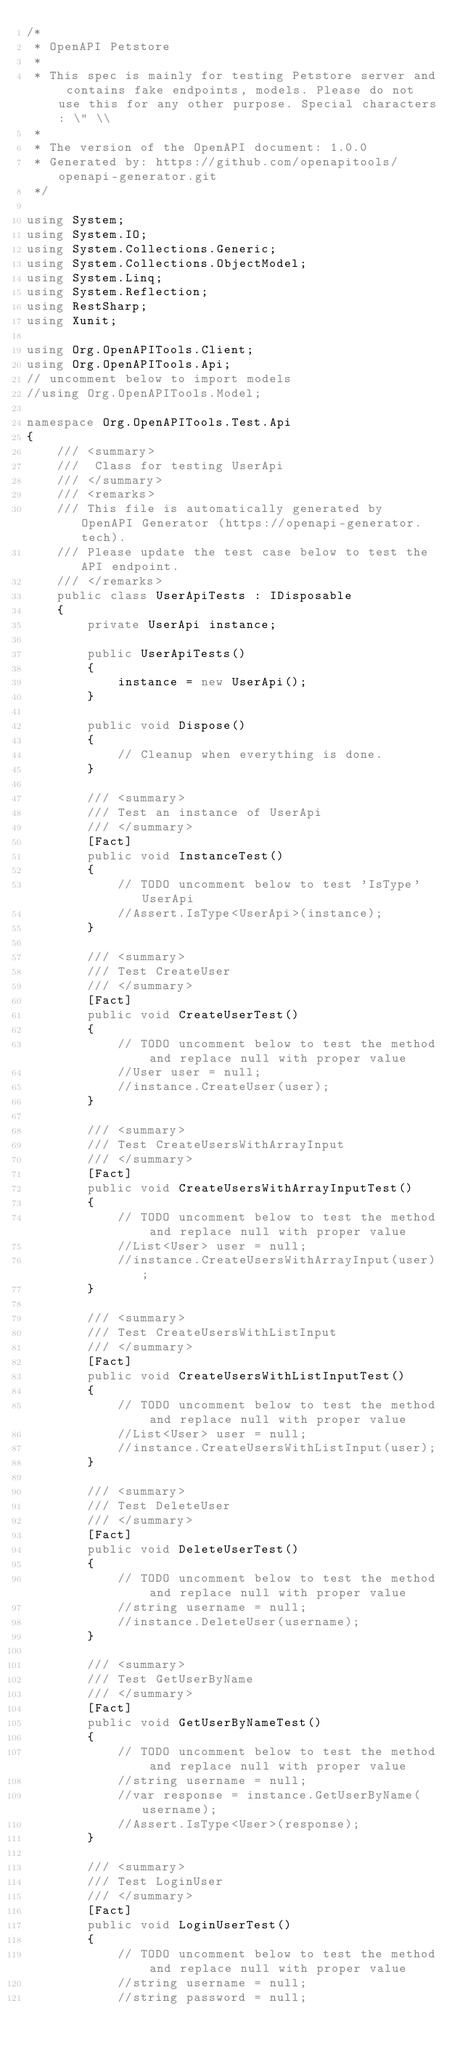Convert code to text. <code><loc_0><loc_0><loc_500><loc_500><_C#_>/*
 * OpenAPI Petstore
 *
 * This spec is mainly for testing Petstore server and contains fake endpoints, models. Please do not use this for any other purpose. Special characters: \" \\
 *
 * The version of the OpenAPI document: 1.0.0
 * Generated by: https://github.com/openapitools/openapi-generator.git
 */

using System;
using System.IO;
using System.Collections.Generic;
using System.Collections.ObjectModel;
using System.Linq;
using System.Reflection;
using RestSharp;
using Xunit;

using Org.OpenAPITools.Client;
using Org.OpenAPITools.Api;
// uncomment below to import models
//using Org.OpenAPITools.Model;

namespace Org.OpenAPITools.Test.Api
{
    /// <summary>
    ///  Class for testing UserApi
    /// </summary>
    /// <remarks>
    /// This file is automatically generated by OpenAPI Generator (https://openapi-generator.tech).
    /// Please update the test case below to test the API endpoint.
    /// </remarks>
    public class UserApiTests : IDisposable
    {
        private UserApi instance;

        public UserApiTests()
        {
            instance = new UserApi();
        }

        public void Dispose()
        {
            // Cleanup when everything is done.
        }

        /// <summary>
        /// Test an instance of UserApi
        /// </summary>
        [Fact]
        public void InstanceTest()
        {
            // TODO uncomment below to test 'IsType' UserApi
            //Assert.IsType<UserApi>(instance);
        }

        /// <summary>
        /// Test CreateUser
        /// </summary>
        [Fact]
        public void CreateUserTest()
        {
            // TODO uncomment below to test the method and replace null with proper value
            //User user = null;
            //instance.CreateUser(user);
        }

        /// <summary>
        /// Test CreateUsersWithArrayInput
        /// </summary>
        [Fact]
        public void CreateUsersWithArrayInputTest()
        {
            // TODO uncomment below to test the method and replace null with proper value
            //List<User> user = null;
            //instance.CreateUsersWithArrayInput(user);
        }

        /// <summary>
        /// Test CreateUsersWithListInput
        /// </summary>
        [Fact]
        public void CreateUsersWithListInputTest()
        {
            // TODO uncomment below to test the method and replace null with proper value
            //List<User> user = null;
            //instance.CreateUsersWithListInput(user);
        }

        /// <summary>
        /// Test DeleteUser
        /// </summary>
        [Fact]
        public void DeleteUserTest()
        {
            // TODO uncomment below to test the method and replace null with proper value
            //string username = null;
            //instance.DeleteUser(username);
        }

        /// <summary>
        /// Test GetUserByName
        /// </summary>
        [Fact]
        public void GetUserByNameTest()
        {
            // TODO uncomment below to test the method and replace null with proper value
            //string username = null;
            //var response = instance.GetUserByName(username);
            //Assert.IsType<User>(response);
        }

        /// <summary>
        /// Test LoginUser
        /// </summary>
        [Fact]
        public void LoginUserTest()
        {
            // TODO uncomment below to test the method and replace null with proper value
            //string username = null;
            //string password = null;</code> 